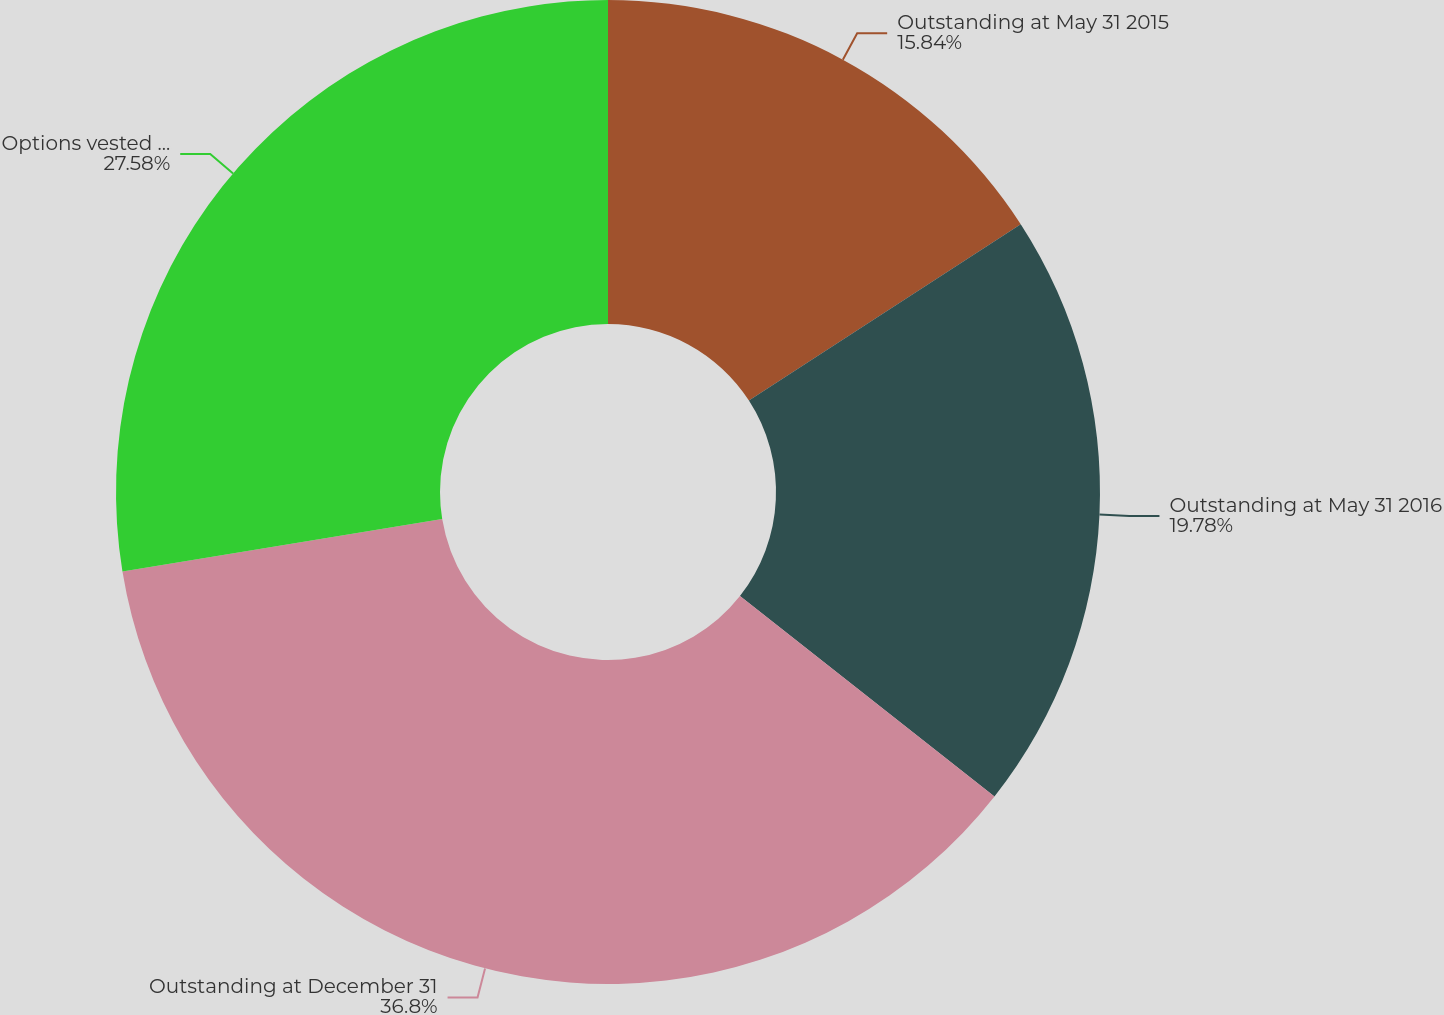Convert chart to OTSL. <chart><loc_0><loc_0><loc_500><loc_500><pie_chart><fcel>Outstanding at May 31 2015<fcel>Outstanding at May 31 2016<fcel>Outstanding at December 31<fcel>Options vested and exercisable<nl><fcel>15.84%<fcel>19.78%<fcel>36.8%<fcel>27.58%<nl></chart> 